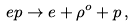Convert formula to latex. <formula><loc_0><loc_0><loc_500><loc_500>e p \to e + \rho ^ { o } + p \, ,</formula> 